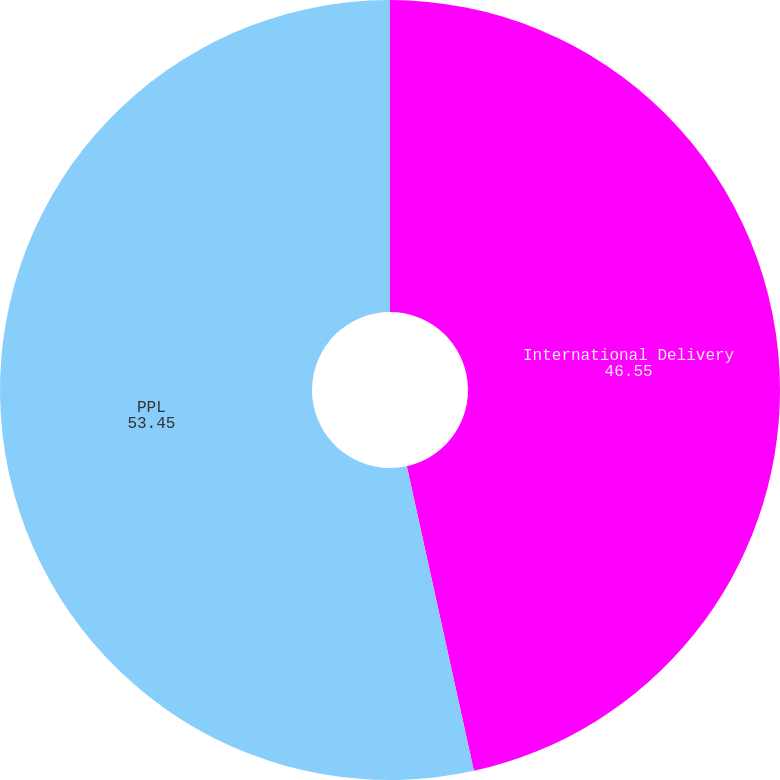Convert chart to OTSL. <chart><loc_0><loc_0><loc_500><loc_500><pie_chart><fcel>International Delivery<fcel>PPL<nl><fcel>46.55%<fcel>53.45%<nl></chart> 